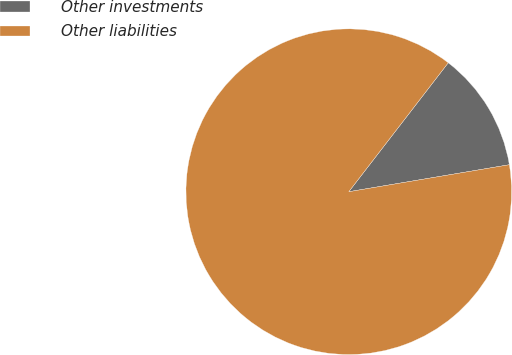Convert chart to OTSL. <chart><loc_0><loc_0><loc_500><loc_500><pie_chart><fcel>Other investments<fcel>Other liabilities<nl><fcel>11.89%<fcel>88.11%<nl></chart> 